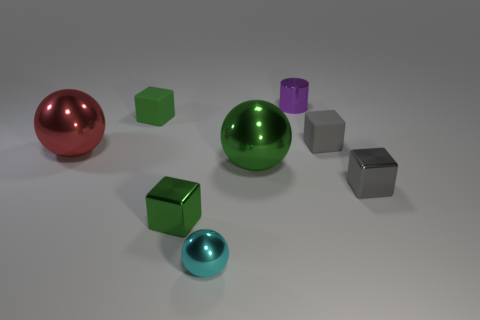There is a rubber object in front of the rubber thing on the left side of the purple shiny object on the right side of the red metallic thing; how big is it?
Your answer should be very brief. Small. Does the cyan metallic object have the same size as the green rubber object?
Keep it short and to the point. Yes. There is a tiny green block that is behind the small gray object behind the red object; what is it made of?
Provide a succinct answer. Rubber. There is a tiny shiny object to the right of the purple metallic cylinder; is it the same shape as the big metallic object in front of the big red thing?
Offer a very short reply. No. Is the number of green objects behind the red shiny thing the same as the number of tiny cyan shiny things?
Provide a short and direct response. Yes. Are there any tiny rubber blocks left of the shiny thing that is behind the small green rubber object?
Your answer should be compact. Yes. Does the large ball that is behind the big green metal ball have the same material as the cylinder?
Your response must be concise. Yes. Are there an equal number of red metallic objects that are behind the cyan metallic sphere and tiny green cubes behind the small purple shiny thing?
Ensure brevity in your answer.  No. What is the size of the green object that is right of the metal block on the left side of the tiny metallic cylinder?
Your response must be concise. Large. What is the tiny cube that is in front of the big red sphere and right of the green shiny ball made of?
Give a very brief answer. Metal. 